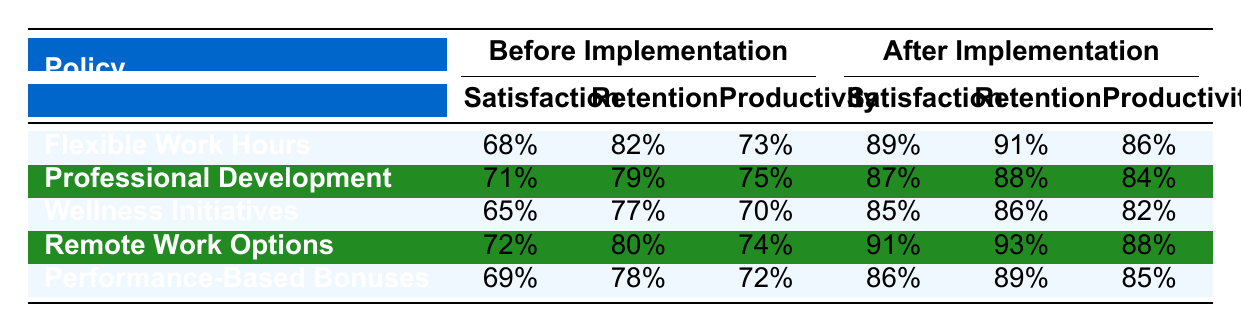What was the employee satisfaction rate before the implementation of Flexible Work Hours? The table shows that the employee satisfaction rate before the implementation of Flexible Work Hours was 68%.
Answer: 68% What is the employee retention rate after implementing Remote Work Options? According to the table, the employee retention rate after implementing Remote Work Options is 93%.
Answer: 93% Which policy saw the greatest increase in employee satisfaction rate from before to after implementation? To find this, we compare the differences: Flexible Work Hours increased from 68% to 89% (21%), Professional Development increased from 71% to 87% (16%), Wellness Initiatives increased from 65% to 85% (20%), Remote Work Options increased from 72% to 91% (19%), and Performance-Based Bonuses increased from 69% to 86% (17%). The greatest increase was from Flexible Work Hours, with an increase of 21%.
Answer: Flexible Work Hours Is it true that all policies resulted in an increase in employee retention after implementation? Looking at the employee retention rates before and after the implementation: Flexible Work Hours (82% to 91%), Professional Development (79% to 88%), Wellness Initiatives (77% to 86%), Remote Work Options (80% to 93%), and Performance-Based Bonuses (78% to 89%). Since all values have increased, the statement is true.
Answer: Yes What is the average productivity score after implementing all policies? We sum the productivity scores after implementation: (86 + 84 + 82 + 88 + 85) = 425. There are five policies, so the average is 425/5 = 85.
Answer: 85 